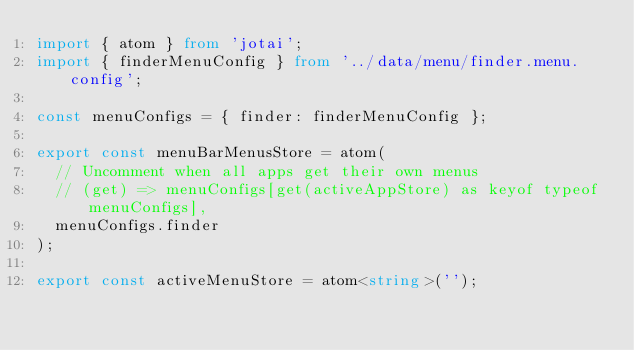<code> <loc_0><loc_0><loc_500><loc_500><_TypeScript_>import { atom } from 'jotai';
import { finderMenuConfig } from '../data/menu/finder.menu.config';

const menuConfigs = { finder: finderMenuConfig };

export const menuBarMenusStore = atom(
  // Uncomment when all apps get their own menus
  // (get) => menuConfigs[get(activeAppStore) as keyof typeof menuConfigs],
  menuConfigs.finder
);

export const activeMenuStore = atom<string>('');
</code> 